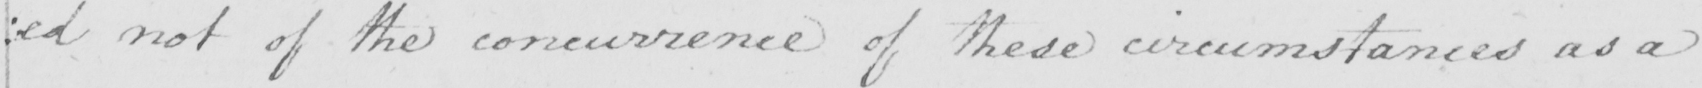What is written in this line of handwriting? : ed not the concurrence of these circumstaces as a 